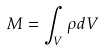Convert formula to latex. <formula><loc_0><loc_0><loc_500><loc_500>M = \int _ { V } \rho d V</formula> 